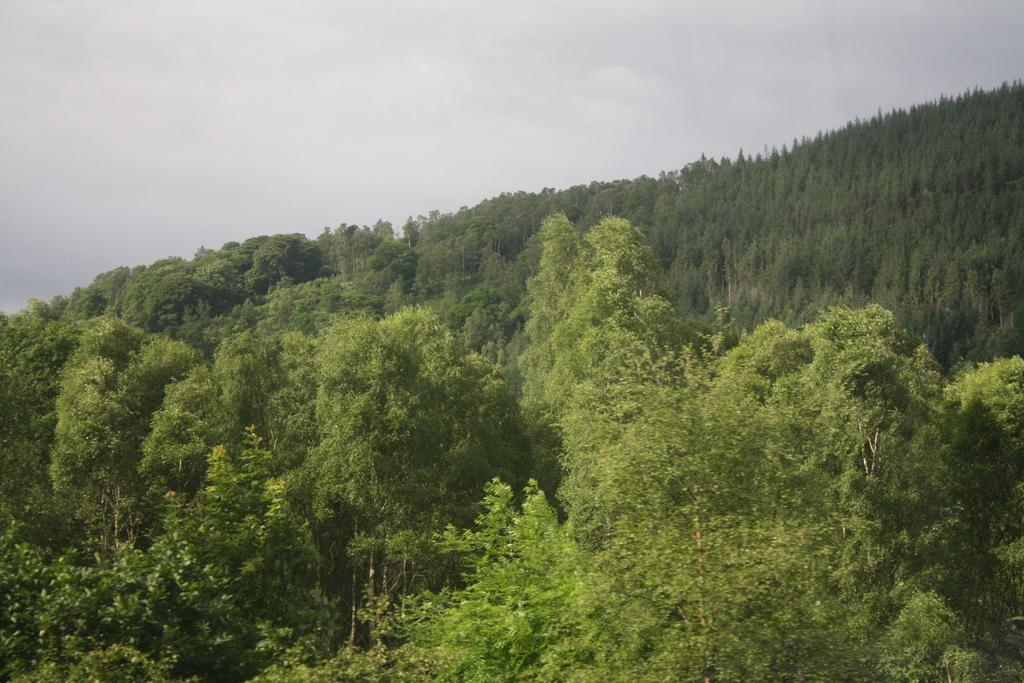What type of vegetation is in the foreground of the image? There are trees in the foreground of the image. What is visible at the top of the image? The sky is visible at the top of the image. What type of power is being protested in the image? There is no indication of a protest or any type of power in the image; it only features trees and the sky. 